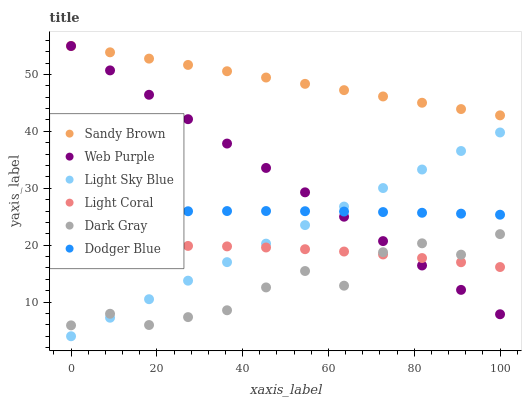Does Dark Gray have the minimum area under the curve?
Answer yes or no. Yes. Does Sandy Brown have the maximum area under the curve?
Answer yes or no. Yes. Does Light Coral have the minimum area under the curve?
Answer yes or no. No. Does Light Coral have the maximum area under the curve?
Answer yes or no. No. Is Light Sky Blue the smoothest?
Answer yes or no. Yes. Is Dark Gray the roughest?
Answer yes or no. Yes. Is Light Coral the smoothest?
Answer yes or no. No. Is Light Coral the roughest?
Answer yes or no. No. Does Light Sky Blue have the lowest value?
Answer yes or no. Yes. Does Light Coral have the lowest value?
Answer yes or no. No. Does Sandy Brown have the highest value?
Answer yes or no. Yes. Does Light Coral have the highest value?
Answer yes or no. No. Is Dodger Blue less than Sandy Brown?
Answer yes or no. Yes. Is Dodger Blue greater than Light Coral?
Answer yes or no. Yes. Does Dark Gray intersect Light Coral?
Answer yes or no. Yes. Is Dark Gray less than Light Coral?
Answer yes or no. No. Is Dark Gray greater than Light Coral?
Answer yes or no. No. Does Dodger Blue intersect Sandy Brown?
Answer yes or no. No. 